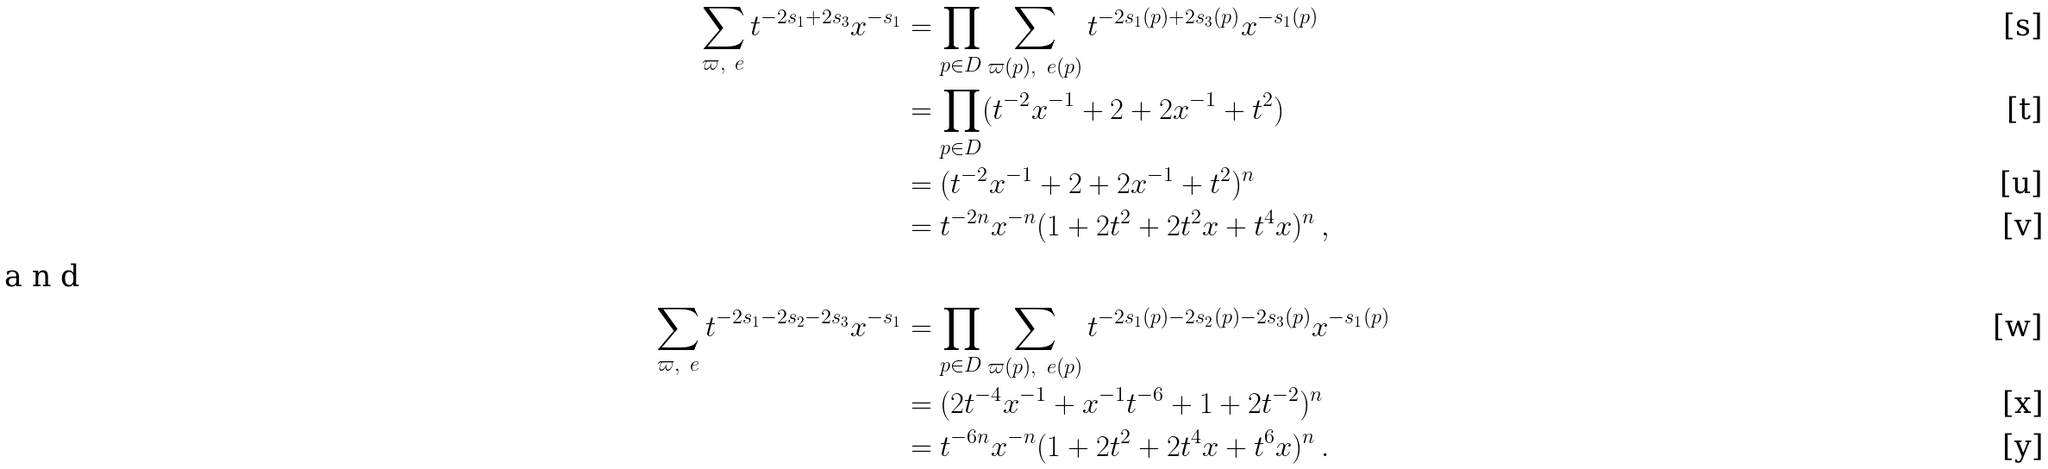<formula> <loc_0><loc_0><loc_500><loc_500>\sum _ { \varpi , \ e } t ^ { - 2 s _ { 1 } + 2 s _ { 3 } } x ^ { - s _ { 1 } } & = \prod _ { p \in D } \sum _ { \varpi ( p ) , \ e ( p ) } t ^ { - 2 s _ { 1 } ( p ) + 2 s _ { 3 } ( p ) } x ^ { - s _ { 1 } ( p ) } \\ & = \prod _ { p \in D } ( t ^ { - 2 } x ^ { - 1 } + 2 + 2 x ^ { - 1 } + t ^ { 2 } ) \\ & = ( t ^ { - 2 } x ^ { - 1 } + 2 + 2 x ^ { - 1 } + t ^ { 2 } ) ^ { n } \\ & = t ^ { - 2 n } x ^ { - n } ( 1 + 2 t ^ { 2 } + 2 t ^ { 2 } x + t ^ { 4 } x ) ^ { n } \, , \\ \intertext { a n d } \sum _ { \varpi , \ e } t ^ { - 2 s _ { 1 } - 2 s _ { 2 } - 2 s _ { 3 } } x ^ { - s _ { 1 } } & = \prod _ { p \in D } \sum _ { \varpi ( p ) , \ e ( p ) } t ^ { - 2 s _ { 1 } ( p ) - 2 s _ { 2 } ( p ) - 2 s _ { 3 } ( p ) } x ^ { - s _ { 1 } ( p ) } \\ & = ( 2 t ^ { - 4 } x ^ { - 1 } + x ^ { - 1 } t ^ { - 6 } + 1 + 2 t ^ { - 2 } ) ^ { n } \\ & = t ^ { - 6 n } x ^ { - n } ( 1 + 2 t ^ { 2 } + 2 t ^ { 4 } x + t ^ { 6 } x ) ^ { n } \, .</formula> 